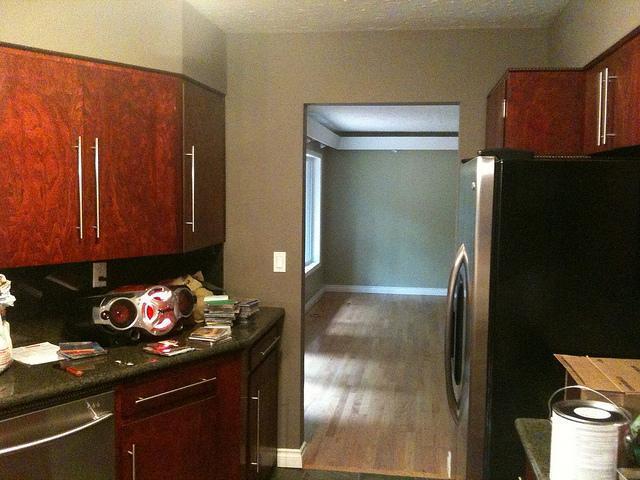How many refrigerators can you see?
Give a very brief answer. 1. 